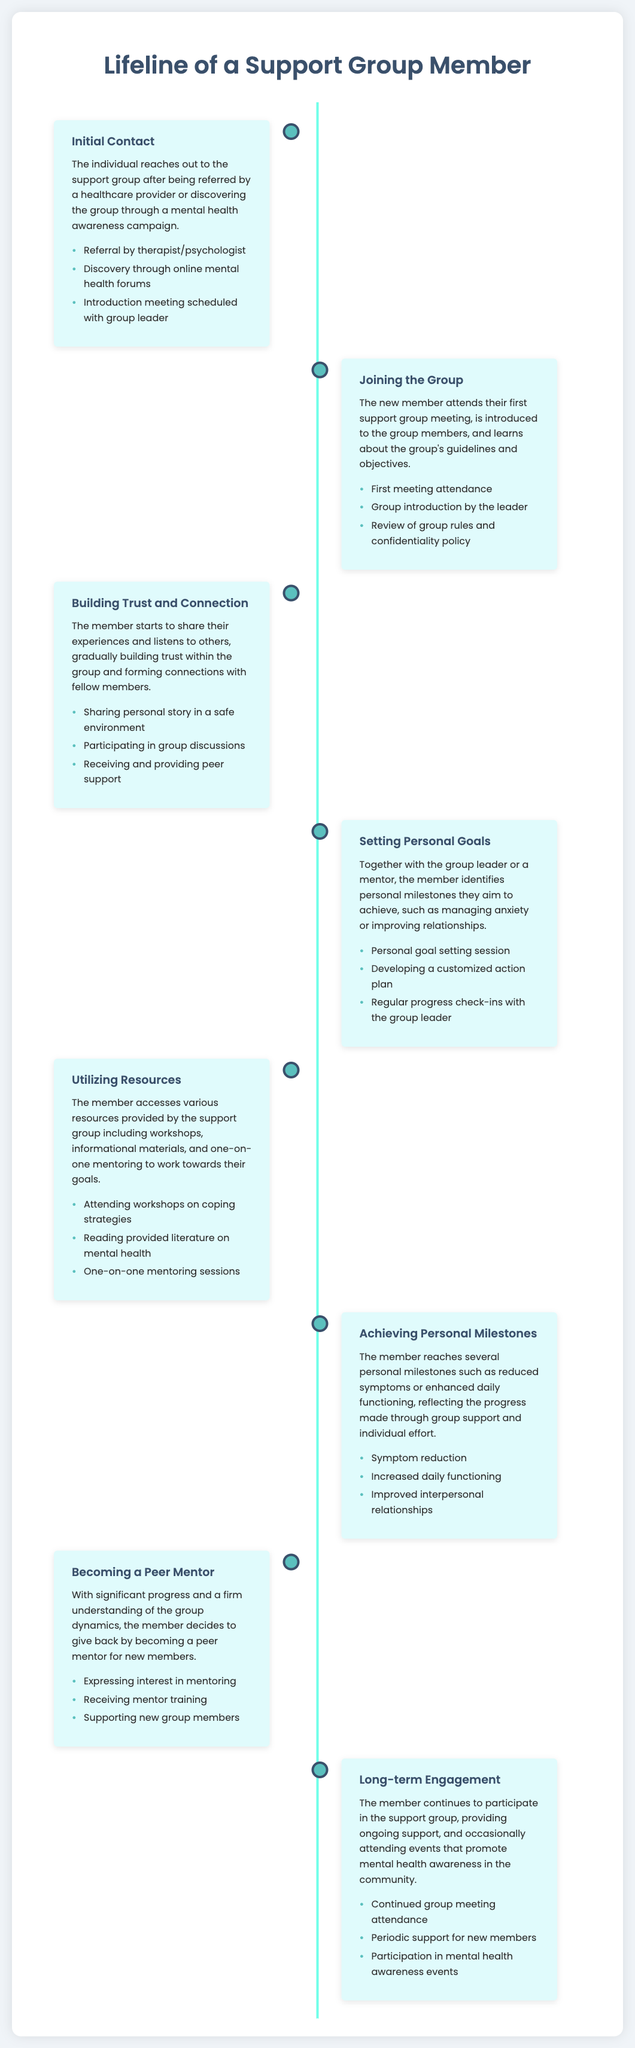What is the first phase in the support group member's journey? The first phase mentioned in the document is "Initial Contact," which refers to when the individual reaches out to the support group.
Answer: Initial Contact What types of resources can members access? The document lists several types of resources, including workshops, informational materials, and one-on-one mentoring.
Answer: Workshops, informational materials, and one-on-one mentoring What milestone focuses on interpersonal relationships? The document specifies that "Achieving Personal Milestones" includes "Improved interpersonal relationships" as a key accomplishment.
Answer: Improved interpersonal relationships What action is taken during the "Setting Personal Goals" phase? The specific action mentioned is "Developing a customized action plan" which is part of identifying personal milestones.
Answer: Developing a customized action plan How does a member give back after achieving progress? The document states that members express interest in mentoring, which explains how they can support new members.
Answer: Becoming a peer mentor In which phase does the member begin to share their experiences? The phase described as "Building Trust and Connection" is when members start sharing their experiences within the group.
Answer: Building Trust and Connection What is the main benefit of "Long-term Engagement" mentioned in the document? The document states that the benefit includes providing ongoing support to new members within the community.
Answer: Ongoing support Which phase involves attending the first meeting? The phase titled "Joining the Group" includes the action of attending their first support group meeting.
Answer: Joining the Group How many phases are described in total in the document? The timeline infographic outlines a total of eight distinct phases explaining the journey of a support group member.
Answer: Eight 